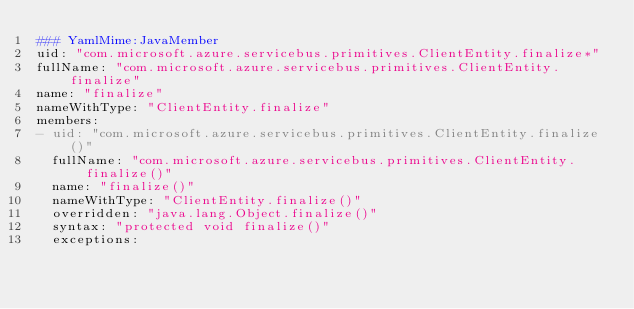<code> <loc_0><loc_0><loc_500><loc_500><_YAML_>### YamlMime:JavaMember
uid: "com.microsoft.azure.servicebus.primitives.ClientEntity.finalize*"
fullName: "com.microsoft.azure.servicebus.primitives.ClientEntity.finalize"
name: "finalize"
nameWithType: "ClientEntity.finalize"
members:
- uid: "com.microsoft.azure.servicebus.primitives.ClientEntity.finalize()"
  fullName: "com.microsoft.azure.servicebus.primitives.ClientEntity.finalize()"
  name: "finalize()"
  nameWithType: "ClientEntity.finalize()"
  overridden: "java.lang.Object.finalize()"
  syntax: "protected void finalize()"
  exceptions:</code> 